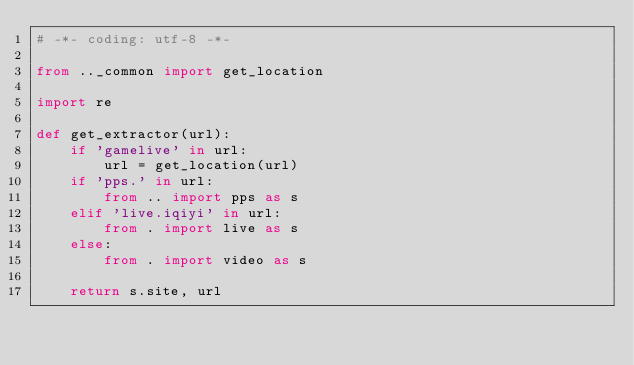<code> <loc_0><loc_0><loc_500><loc_500><_Python_># -*- coding: utf-8 -*-

from .._common import get_location

import re

def get_extractor(url):
    if 'gamelive' in url:
        url = get_location(url)
    if 'pps.' in url:
        from .. import pps as s
    elif 'live.iqiyi' in url:
        from . import live as s
    else:
        from . import video as s

    return s.site, url
</code> 